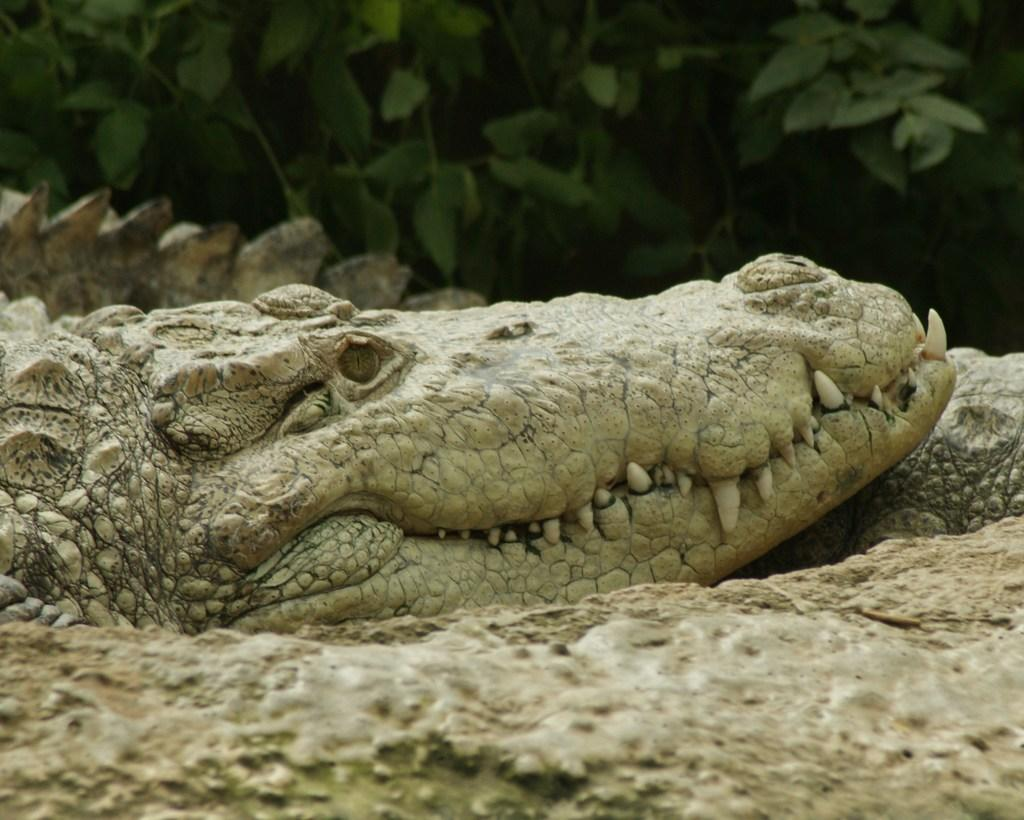What animal is present in the image? There is a crocodile in the image. Where is the crocodile located? The crocodile is on the ground. What can be seen in the background of the image? There are trees in the background of the image. What type of songs can be heard being sung by the babies in the image? There are no babies present in the image, so there are no songs being sung. 